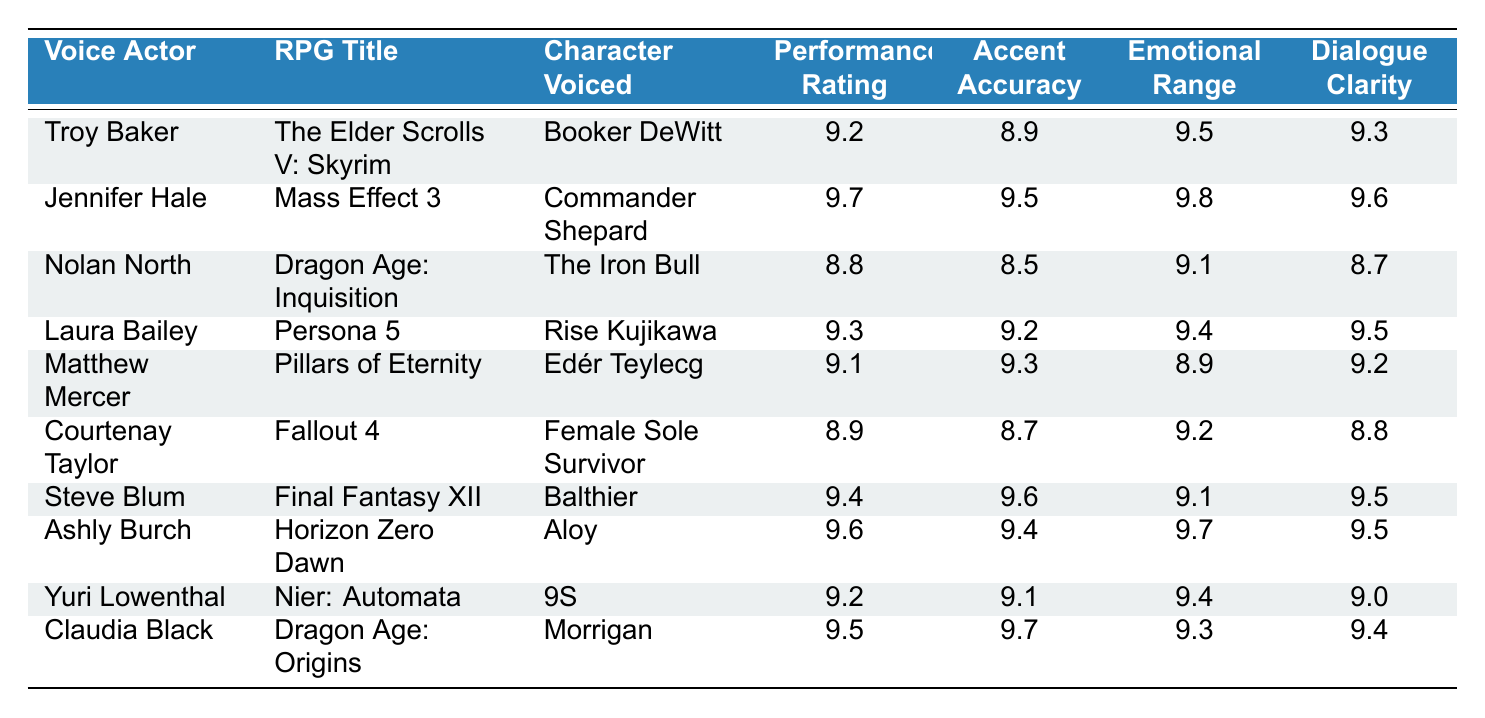What is the highest performance rating among the voice actors? The highest performance rating in the table is listed under Jennifer Hale for the character Commander Shepard in Mass Effect 3, which is 9.7.
Answer: 9.7 Which voice actor performed in the RPG title "Horizon Zero Dawn"? Ashly Burch voiced the character Aloy in the RPG title Horizon Zero Dawn, as shown in the table.
Answer: Ashly Burch What is the average performance rating of the voice actors listed? To calculate the average, sum all performance ratings: (9.2 + 9.7 + 8.8 + 9.3 + 9.1 + 8.9 + 9.4 + 9.6 + 9.2 + 9.5) = 92.7, then divide by the number of entries (10), which gives 92.7/10 = 9.27.
Answer: 9.27 Which RPG title has the lowest accent accuracy? The RPG title with the lowest accent accuracy is Dragon Age: Inquisition (voiced by Nolan North), with an accent accuracy of 8.5.
Answer: Dragon Age: Inquisition Is Claudia Black's emotional range rating higher than 9.0? Claudia Black's emotional range rating is 9.3, which is higher than 9.0. Therefore, the statement is true.
Answer: Yes How many voice actors have a performance rating above 9.4? The voice actors who have a performance rating above 9.4 are Jennifer Hale, Ashly Burch, and Steve Blum. That totals to 3 voice actors.
Answer: 3 Which character voiced by Troy Baker had a performance rating better than 9.0? Troy Baker voiced Booker DeWitt in Skyrim, and his performance rating is 9.2, which is indeed better than 9.0.
Answer: Yes What is the dialogue clarity rating of the character voiced by Matthew Mercer? Matthew Mercer voiced Edér Teylecg in Pillars of Eternity, and his dialogue clarity rating is 9.2 as indicated in the table.
Answer: 9.2 Which RPG title has both the highest performance rating and emotional range rating? The RPG title Mass Effect 3 has the highest performance rating at 9.7 and the highest emotional range rating at 9.8 for Jennifer Hale.
Answer: Mass Effect 3 How many characters in the table were voiced by actors who received a performance rating of 9.5 or higher? The characters voiced by actors with a performance rating of 9.5 or higher are Booker DeWitt, Commander Shepard, Rise Kujikawa, Aloy, and Morrigan. That's a total of 5 characters.
Answer: 5 